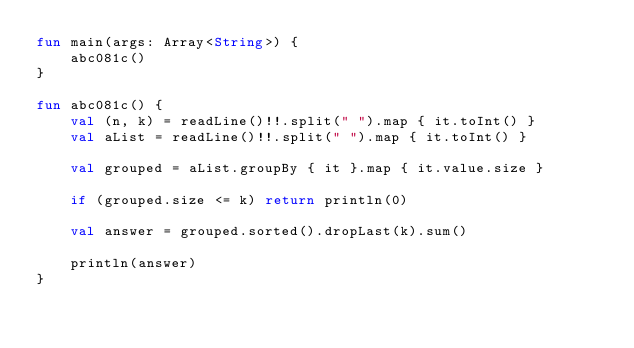<code> <loc_0><loc_0><loc_500><loc_500><_Kotlin_>fun main(args: Array<String>) {
    abc081c()
}

fun abc081c() {
    val (n, k) = readLine()!!.split(" ").map { it.toInt() }
    val aList = readLine()!!.split(" ").map { it.toInt() }

    val grouped = aList.groupBy { it }.map { it.value.size }

    if (grouped.size <= k) return println(0)

    val answer = grouped.sorted().dropLast(k).sum()

    println(answer)
}
</code> 